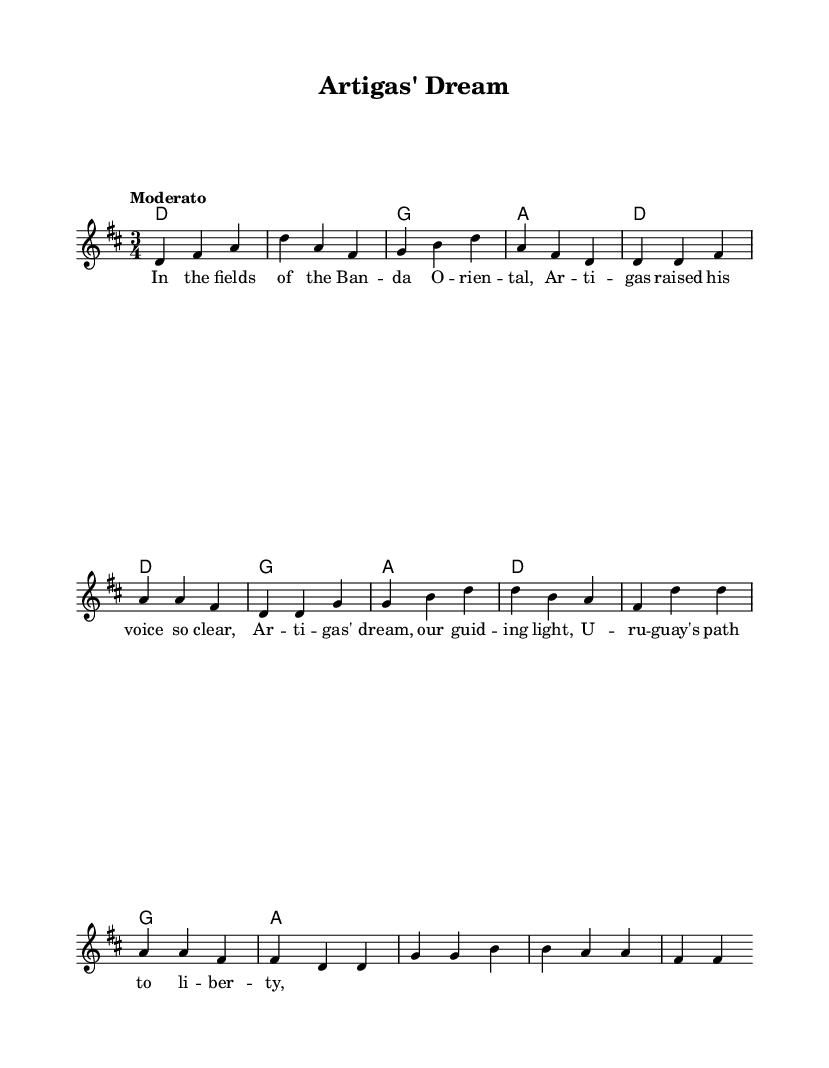What is the key signature of this music? The key signature is D major, which has two sharps (F# and C#). You can determine this by examining the key signature notation at the beginning of the sheet music.
Answer: D major What is the time signature of this music? The time signature is 3/4, indicating that there are three beats in each measure and the quarter note gets one beat. This can be found at the beginning of the score, where the time signature is noted.
Answer: 3/4 What is the tempo marking for this piece? The tempo marking is "Moderato", which suggests a moderate speed of play. This is indicated in the score near the top where tempo is indicated.
Answer: Moderato Which chord is played in the intro? The first chord in the intro is D major. You can identify it by looking at the chord notations at the beginning of the sheet music, where the chord changes are written.
Answer: D What is the first line of the lyrics? The first line of the lyrics is "In the fields of the Banda Oriental". This is found in the lyrics section under the melody where the text is assigned to the corresponding notes.
Answer: In the fields of the Banda Oriental What is the structure of the song based on the parts included? The song consists of an intro, one partial verse, and a chorus. This can be inferred from the layout of the sections in the sheet music where the parts are indicated.
Answer: Intro, Verse 1 (partial), Chorus How many measures are in the chorus? There are four measures in the chorus. By counting the measures listed under the section labeled "Chorus," you can see the number of individual measures.
Answer: 4 